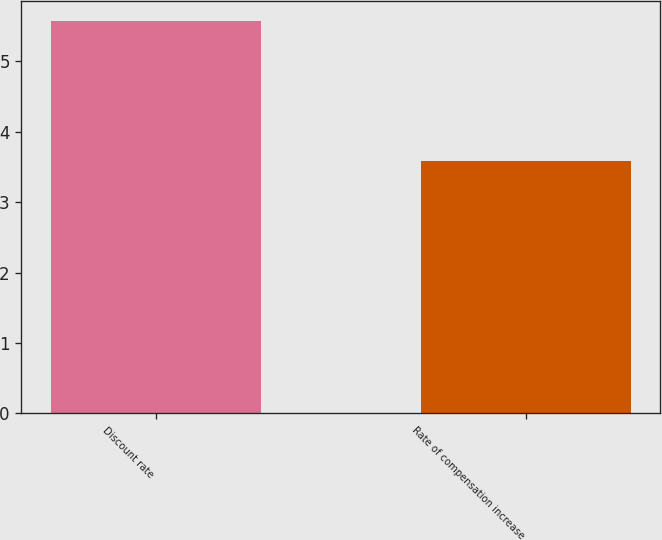Convert chart to OTSL. <chart><loc_0><loc_0><loc_500><loc_500><bar_chart><fcel>Discount rate<fcel>Rate of compensation increase<nl><fcel>5.57<fcel>3.59<nl></chart> 